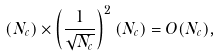<formula> <loc_0><loc_0><loc_500><loc_500>( N _ { c } ) \times \left ( \frac { 1 } { \sqrt { N _ { c } } } \right ) ^ { 2 } ( N _ { c } ) = O ( N _ { c } ) ,</formula> 